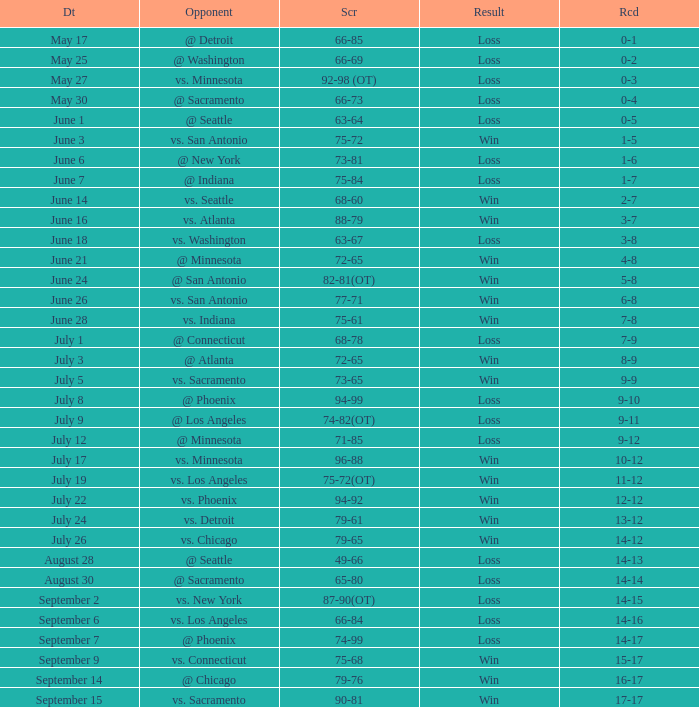What is the Date of the game with a Loss and Record of 7-9? July 1. 